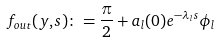Convert formula to latex. <formula><loc_0><loc_0><loc_500><loc_500>f _ { o u t } ( y , s ) \colon = \frac { \pi } { 2 } + a _ { l } ( 0 ) e ^ { - \lambda _ { l } s } \phi _ { l }</formula> 